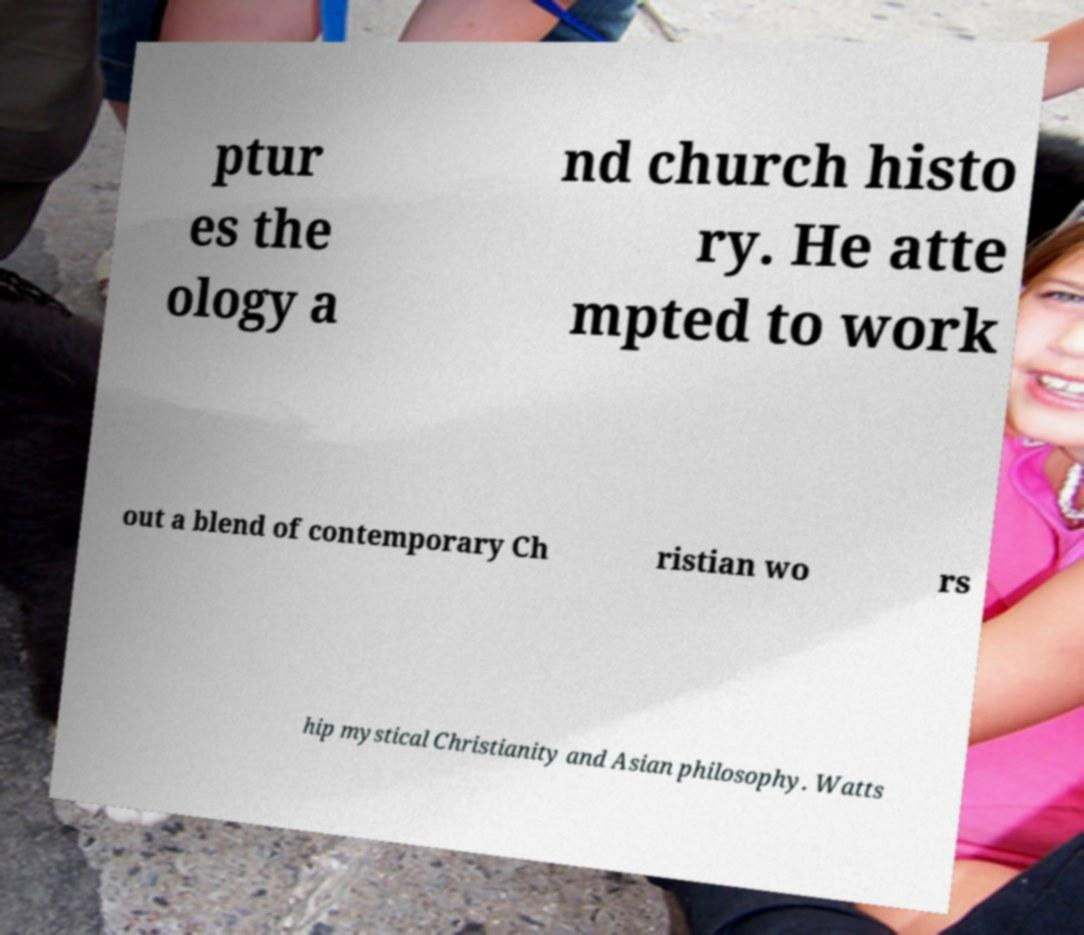Can you accurately transcribe the text from the provided image for me? ptur es the ology a nd church histo ry. He atte mpted to work out a blend of contemporary Ch ristian wo rs hip mystical Christianity and Asian philosophy. Watts 